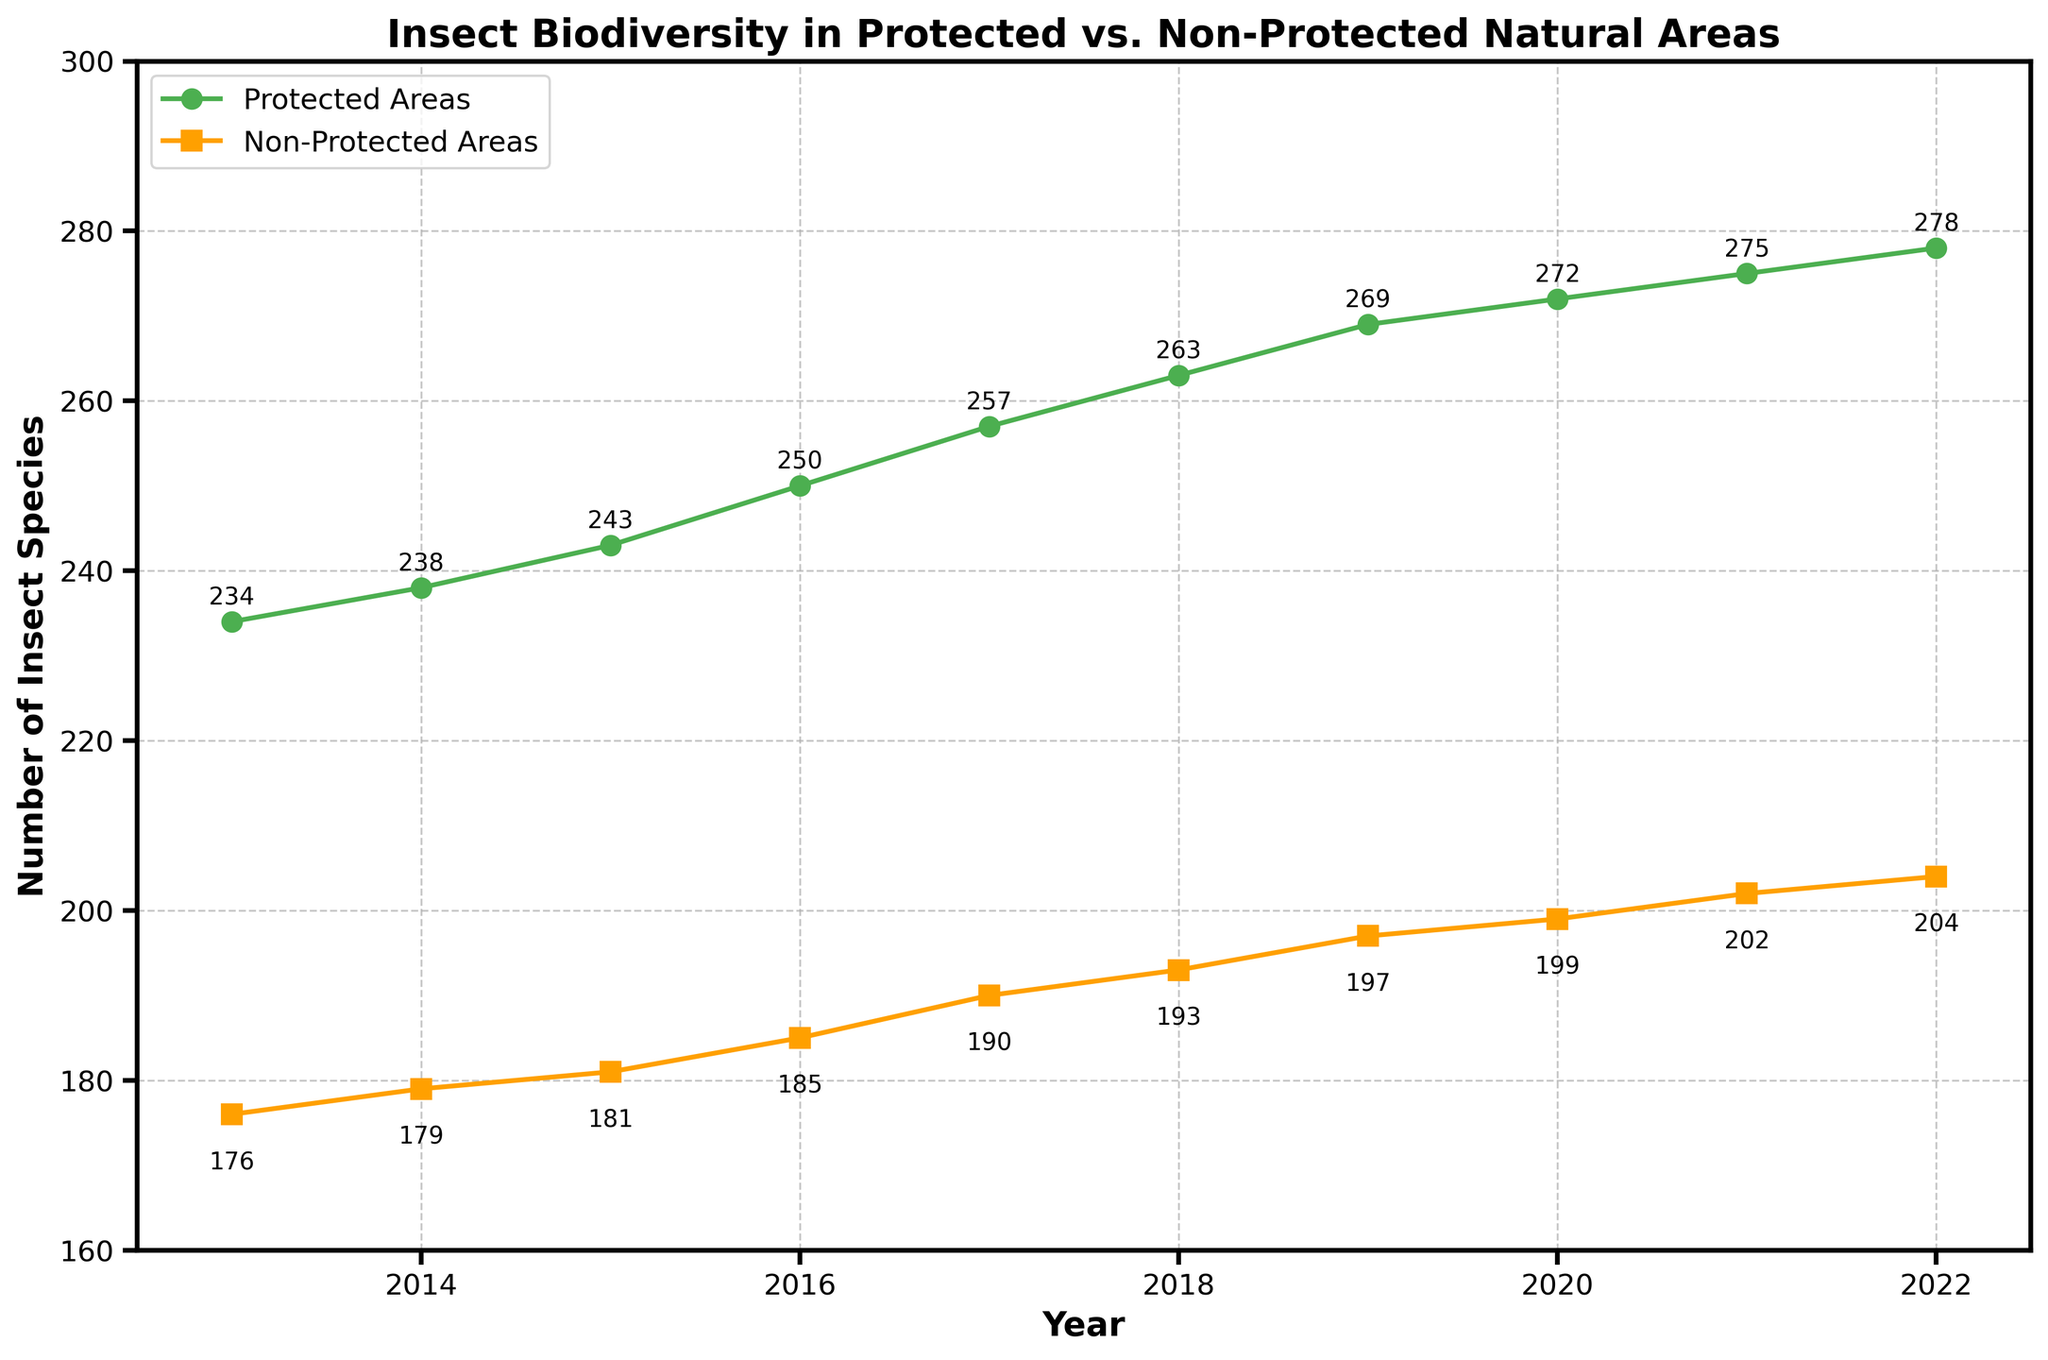What's the title of the plot? The title of the plot is displayed at the top and it is meant to provide a succinct summary of what the plot is about. Here, it reads "Insect Biodiversity in Protected vs. Non-Protected Natural Areas".
Answer: Insect Biodiversity in Protected vs. Non-Protected Natural Areas How many insect species were found in protected areas in 2020? To find the number of insect species in protected areas in 2020, look at the point corresponding to the year 2020 on the green line. An annotation near this point shows the exact value.
Answer: 272 Which year shows the smallest difference in the number of insect species between protected and non-protected areas? To determine the smallest difference, subtract the values of non-protected areas from protected areas for each year and find the minimum difference. In 2020, the difference is 272 - 199 = 73, which is the smallest difference across all years.
Answer: 2020 What's the trend in the number of insect species in both protected and non-protected areas over the decade? The trend can be identified by observing the slope and direction of the lines. Both the green and orange lines show an upward slope from 2013 to 2022. This indicates that the number of insect species has been increasing in both protected and non-protected areas over the decade.
Answer: Increasing How many more species were found in protected areas compared to non-protected areas in 2022? Subtract the number of species in non-protected areas from that in protected areas for the year 2022. For 2022: 278 (protected) - 204 (non-protected) = 74.
Answer: 74 Which year shows the highest number of insect species in non-protected areas? Examine the annotations for the orange line corresponding to each year. The highest annotated value is found in 2022, which is 204 species.
Answer: 2022 What's the average number of insect species in protected areas over the decade? Sum up all the values for protected areas and divide by the number of years (10). (234+238+243+250+257+263+269+272+275+278) / 10 = 2579 / 10 = 257.9
Answer: 257.9 Between 2016 and 2020, how much did the number of insect species increase in protected areas? Subtract the number of protected area species in 2016 from that in 2020. For 2016: 250, and 2020: 272. 272 - 250 = 22.
Answer: 22 By how many species did the number of insect species in non-protected areas increase from 2013 to 2022? Subtract the number of non-protected area species in 2013 from that in 2022. For 2013: 176, and 2022: 204. 204 - 176 = 28.
Answer: 28 